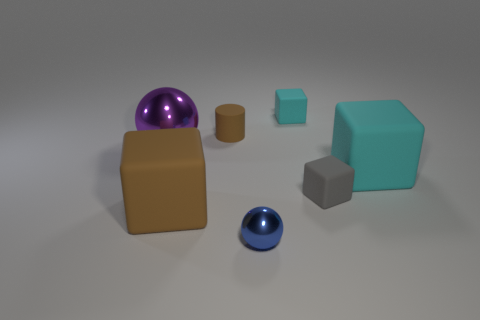Add 2 tiny gray matte blocks. How many objects exist? 9 Subtract all brown matte blocks. How many blocks are left? 3 Subtract all blocks. How many objects are left? 3 Subtract 1 balls. How many balls are left? 1 Add 7 green shiny objects. How many green shiny objects exist? 7 Subtract all cyan blocks. How many blocks are left? 2 Subtract 0 gray cylinders. How many objects are left? 7 Subtract all purple cylinders. Subtract all gray spheres. How many cylinders are left? 1 Subtract all red cylinders. How many cyan blocks are left? 2 Subtract all large brown things. Subtract all big purple objects. How many objects are left? 5 